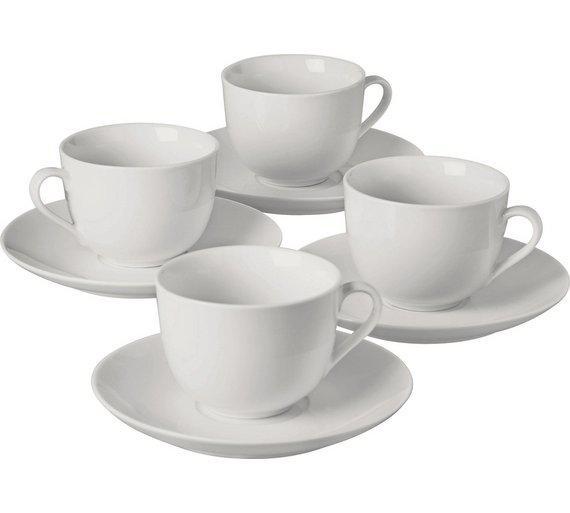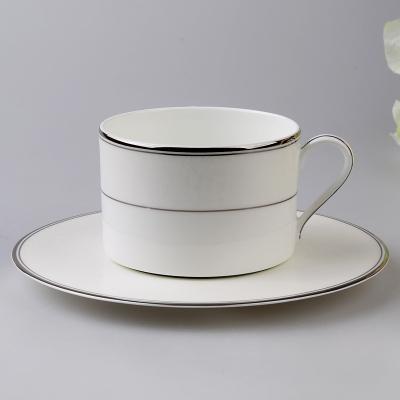The first image is the image on the left, the second image is the image on the right. Evaluate the accuracy of this statement regarding the images: "An image contains exactly four cups on saucers.". Is it true? Answer yes or no. Yes. The first image is the image on the left, the second image is the image on the right. Analyze the images presented: Is the assertion "There are two teacup and saucer sets" valid? Answer yes or no. No. 